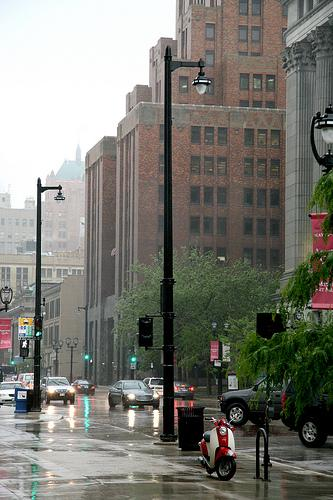Mention the color of the traffic light and what it is indicating for pedestrians. The traffic light is showing green, signaling that it is okay for pedestrians to cross the street. What can you deduce about the environment and location where the image was taken? The image seems to be taken in a city street with multiple buildings, pedestrian and vehicular traffic, streetlights, and vegetation along the sidewalk, possibly during or after rainfall. Describe the appearance of the buildings in the distance. The buildings in the distance appear misty, possibly due to weather conditions or the time of day. What kind of vegetation is visible in the image? There are tree branches and round, long-limbed trees in front of the buildings on the street. Are there any objects that seem to be partially obscured by other objects in the image? If so, describe them. Tree branches are partially obscuring the view of two vehicles, and a partially visible grey building can be seen with massive pillars. Mention any objects related to print media found in the image and their distinct color. A dark blue dispenser of reading material, possibly for periodicals and books, can be seen in the image. What type of vehicle is parked prominently in the image and what are its colors? A red and white parked motorbike, which could be a scooter, is prominently visible in the image. How would you describe the weather conditions and lighting in the image? The weather appears to be rainy or just after a rain, creating a reflective and wet sidewalk and street, with cars having their headlights and rear lights on for visibility. Describe any interesting objects or features related to the streetlights in the image. There are two tall black posts that suspend street lamps high above ground level, and a pair of street lights showing blue. Identify the primary object of interest and its state in the image. A tall brick building with several levels is the main focus, possibly on a rainy day as the ground and sidewalk appear wet with rain. 